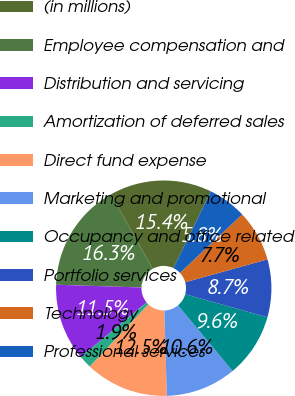<chart> <loc_0><loc_0><loc_500><loc_500><pie_chart><fcel>(in millions)<fcel>Employee compensation and<fcel>Distribution and servicing<fcel>Amortization of deferred sales<fcel>Direct fund expense<fcel>Marketing and promotional<fcel>Occupancy and office related<fcel>Portfolio services<fcel>Technology<fcel>Professional services<nl><fcel>15.37%<fcel>16.33%<fcel>11.53%<fcel>1.95%<fcel>12.49%<fcel>10.58%<fcel>9.62%<fcel>8.66%<fcel>7.7%<fcel>5.78%<nl></chart> 